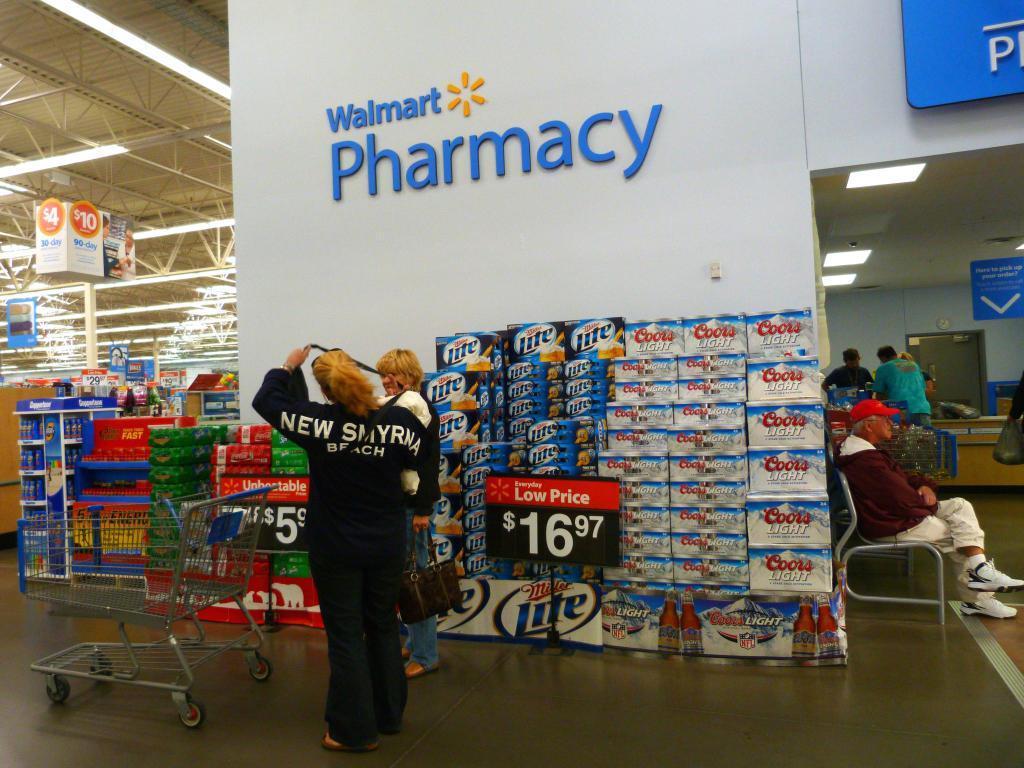How would you summarize this image in a sentence or two? The image is taken in walmart store. In the foreground of the picture there are two women, cart, boxes, prize boards and many other objects. On the right there are people, boards, desk, carts and other objects. On the left there are lights, banners, boards and various things. 